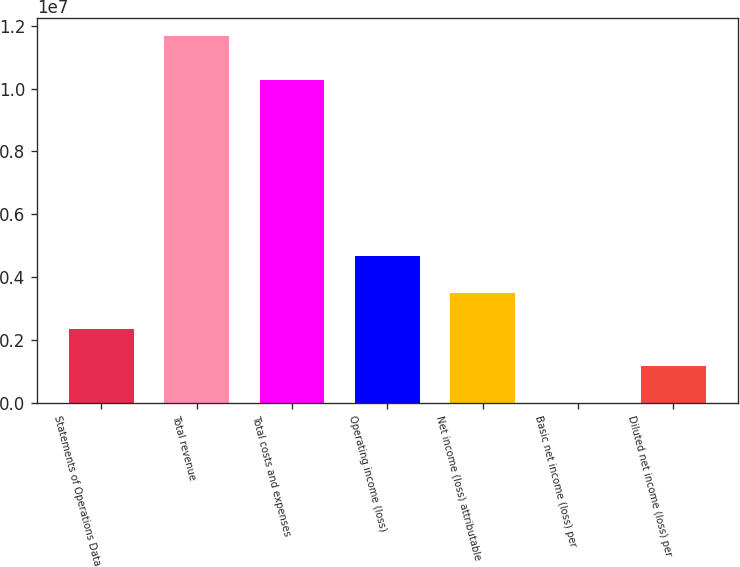Convert chart to OTSL. <chart><loc_0><loc_0><loc_500><loc_500><bar_chart><fcel>Statements of Operations Data<fcel>Total revenue<fcel>Total costs and expenses<fcel>Operating income (loss)<fcel>Net income (loss) attributable<fcel>Basic net income (loss) per<fcel>Diluted net income (loss) per<nl><fcel>2.33283e+06<fcel>1.16642e+07<fcel>1.02772e+07<fcel>4.66566e+06<fcel>3.49925e+06<fcel>1.42<fcel>1.16642e+06<nl></chart> 